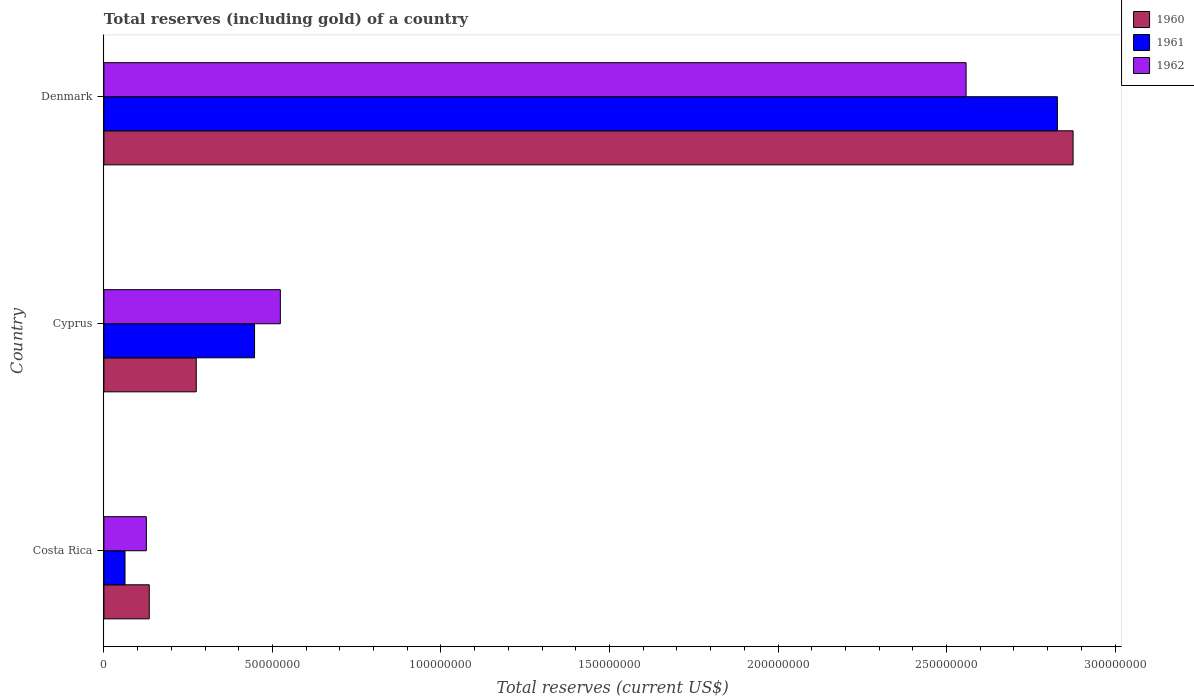How many groups of bars are there?
Make the answer very short. 3. Are the number of bars on each tick of the Y-axis equal?
Provide a succinct answer. Yes. How many bars are there on the 1st tick from the top?
Provide a succinct answer. 3. How many bars are there on the 3rd tick from the bottom?
Provide a short and direct response. 3. What is the label of the 3rd group of bars from the top?
Offer a terse response. Costa Rica. In how many cases, is the number of bars for a given country not equal to the number of legend labels?
Ensure brevity in your answer.  0. What is the total reserves (including gold) in 1961 in Cyprus?
Make the answer very short. 4.47e+07. Across all countries, what is the maximum total reserves (including gold) in 1962?
Give a very brief answer. 2.56e+08. Across all countries, what is the minimum total reserves (including gold) in 1960?
Keep it short and to the point. 1.35e+07. In which country was the total reserves (including gold) in 1961 maximum?
Keep it short and to the point. Denmark. What is the total total reserves (including gold) in 1961 in the graph?
Ensure brevity in your answer.  3.34e+08. What is the difference between the total reserves (including gold) in 1961 in Cyprus and that in Denmark?
Provide a succinct answer. -2.38e+08. What is the difference between the total reserves (including gold) in 1962 in Denmark and the total reserves (including gold) in 1961 in Costa Rica?
Ensure brevity in your answer.  2.50e+08. What is the average total reserves (including gold) in 1962 per country?
Offer a terse response. 1.07e+08. What is the difference between the total reserves (including gold) in 1962 and total reserves (including gold) in 1961 in Denmark?
Keep it short and to the point. -2.71e+07. In how many countries, is the total reserves (including gold) in 1961 greater than 180000000 US$?
Your answer should be compact. 1. What is the ratio of the total reserves (including gold) in 1961 in Cyprus to that in Denmark?
Your answer should be very brief. 0.16. Is the difference between the total reserves (including gold) in 1962 in Costa Rica and Denmark greater than the difference between the total reserves (including gold) in 1961 in Costa Rica and Denmark?
Ensure brevity in your answer.  Yes. What is the difference between the highest and the second highest total reserves (including gold) in 1962?
Offer a very short reply. 2.03e+08. What is the difference between the highest and the lowest total reserves (including gold) in 1961?
Ensure brevity in your answer.  2.77e+08. In how many countries, is the total reserves (including gold) in 1962 greater than the average total reserves (including gold) in 1962 taken over all countries?
Make the answer very short. 1. What does the 1st bar from the top in Denmark represents?
Your answer should be compact. 1962. What does the 2nd bar from the bottom in Cyprus represents?
Offer a terse response. 1961. Is it the case that in every country, the sum of the total reserves (including gold) in 1962 and total reserves (including gold) in 1960 is greater than the total reserves (including gold) in 1961?
Your answer should be very brief. Yes. How many bars are there?
Keep it short and to the point. 9. Are the values on the major ticks of X-axis written in scientific E-notation?
Provide a succinct answer. No. Does the graph contain grids?
Offer a very short reply. No. How many legend labels are there?
Give a very brief answer. 3. How are the legend labels stacked?
Keep it short and to the point. Vertical. What is the title of the graph?
Your response must be concise. Total reserves (including gold) of a country. Does "1997" appear as one of the legend labels in the graph?
Offer a very short reply. No. What is the label or title of the X-axis?
Your response must be concise. Total reserves (current US$). What is the Total reserves (current US$) of 1960 in Costa Rica?
Your response must be concise. 1.35e+07. What is the Total reserves (current US$) in 1961 in Costa Rica?
Offer a very short reply. 6.26e+06. What is the Total reserves (current US$) in 1962 in Costa Rica?
Give a very brief answer. 1.26e+07. What is the Total reserves (current US$) of 1960 in Cyprus?
Your answer should be very brief. 2.74e+07. What is the Total reserves (current US$) in 1961 in Cyprus?
Give a very brief answer. 4.47e+07. What is the Total reserves (current US$) in 1962 in Cyprus?
Offer a very short reply. 5.23e+07. What is the Total reserves (current US$) of 1960 in Denmark?
Your response must be concise. 2.88e+08. What is the Total reserves (current US$) in 1961 in Denmark?
Offer a terse response. 2.83e+08. What is the Total reserves (current US$) in 1962 in Denmark?
Make the answer very short. 2.56e+08. Across all countries, what is the maximum Total reserves (current US$) of 1960?
Keep it short and to the point. 2.88e+08. Across all countries, what is the maximum Total reserves (current US$) of 1961?
Give a very brief answer. 2.83e+08. Across all countries, what is the maximum Total reserves (current US$) in 1962?
Your response must be concise. 2.56e+08. Across all countries, what is the minimum Total reserves (current US$) of 1960?
Your answer should be compact. 1.35e+07. Across all countries, what is the minimum Total reserves (current US$) in 1961?
Provide a short and direct response. 6.26e+06. Across all countries, what is the minimum Total reserves (current US$) of 1962?
Your answer should be compact. 1.26e+07. What is the total Total reserves (current US$) of 1960 in the graph?
Ensure brevity in your answer.  3.28e+08. What is the total Total reserves (current US$) in 1961 in the graph?
Keep it short and to the point. 3.34e+08. What is the total Total reserves (current US$) of 1962 in the graph?
Offer a terse response. 3.21e+08. What is the difference between the Total reserves (current US$) of 1960 in Costa Rica and that in Cyprus?
Make the answer very short. -1.39e+07. What is the difference between the Total reserves (current US$) of 1961 in Costa Rica and that in Cyprus?
Give a very brief answer. -3.84e+07. What is the difference between the Total reserves (current US$) in 1962 in Costa Rica and that in Cyprus?
Provide a succinct answer. -3.98e+07. What is the difference between the Total reserves (current US$) of 1960 in Costa Rica and that in Denmark?
Provide a succinct answer. -2.74e+08. What is the difference between the Total reserves (current US$) in 1961 in Costa Rica and that in Denmark?
Offer a terse response. -2.77e+08. What is the difference between the Total reserves (current US$) in 1962 in Costa Rica and that in Denmark?
Provide a succinct answer. -2.43e+08. What is the difference between the Total reserves (current US$) of 1960 in Cyprus and that in Denmark?
Offer a terse response. -2.60e+08. What is the difference between the Total reserves (current US$) in 1961 in Cyprus and that in Denmark?
Provide a short and direct response. -2.38e+08. What is the difference between the Total reserves (current US$) of 1962 in Cyprus and that in Denmark?
Your response must be concise. -2.03e+08. What is the difference between the Total reserves (current US$) in 1960 in Costa Rica and the Total reserves (current US$) in 1961 in Cyprus?
Your answer should be very brief. -3.12e+07. What is the difference between the Total reserves (current US$) in 1960 in Costa Rica and the Total reserves (current US$) in 1962 in Cyprus?
Offer a very short reply. -3.89e+07. What is the difference between the Total reserves (current US$) of 1961 in Costa Rica and the Total reserves (current US$) of 1962 in Cyprus?
Keep it short and to the point. -4.61e+07. What is the difference between the Total reserves (current US$) of 1960 in Costa Rica and the Total reserves (current US$) of 1961 in Denmark?
Give a very brief answer. -2.69e+08. What is the difference between the Total reserves (current US$) of 1960 in Costa Rica and the Total reserves (current US$) of 1962 in Denmark?
Provide a succinct answer. -2.42e+08. What is the difference between the Total reserves (current US$) in 1961 in Costa Rica and the Total reserves (current US$) in 1962 in Denmark?
Provide a short and direct response. -2.50e+08. What is the difference between the Total reserves (current US$) in 1960 in Cyprus and the Total reserves (current US$) in 1961 in Denmark?
Your answer should be compact. -2.55e+08. What is the difference between the Total reserves (current US$) in 1960 in Cyprus and the Total reserves (current US$) in 1962 in Denmark?
Make the answer very short. -2.28e+08. What is the difference between the Total reserves (current US$) of 1961 in Cyprus and the Total reserves (current US$) of 1962 in Denmark?
Your response must be concise. -2.11e+08. What is the average Total reserves (current US$) in 1960 per country?
Give a very brief answer. 1.09e+08. What is the average Total reserves (current US$) of 1961 per country?
Provide a short and direct response. 1.11e+08. What is the average Total reserves (current US$) in 1962 per country?
Your response must be concise. 1.07e+08. What is the difference between the Total reserves (current US$) of 1960 and Total reserves (current US$) of 1961 in Costa Rica?
Keep it short and to the point. 7.20e+06. What is the difference between the Total reserves (current US$) of 1960 and Total reserves (current US$) of 1962 in Costa Rica?
Keep it short and to the point. 8.62e+05. What is the difference between the Total reserves (current US$) in 1961 and Total reserves (current US$) in 1962 in Costa Rica?
Your answer should be very brief. -6.34e+06. What is the difference between the Total reserves (current US$) in 1960 and Total reserves (current US$) in 1961 in Cyprus?
Keep it short and to the point. -1.73e+07. What is the difference between the Total reserves (current US$) in 1960 and Total reserves (current US$) in 1962 in Cyprus?
Provide a succinct answer. -2.49e+07. What is the difference between the Total reserves (current US$) in 1961 and Total reserves (current US$) in 1962 in Cyprus?
Provide a short and direct response. -7.65e+06. What is the difference between the Total reserves (current US$) in 1960 and Total reserves (current US$) in 1961 in Denmark?
Provide a short and direct response. 4.67e+06. What is the difference between the Total reserves (current US$) in 1960 and Total reserves (current US$) in 1962 in Denmark?
Make the answer very short. 3.17e+07. What is the difference between the Total reserves (current US$) in 1961 and Total reserves (current US$) in 1962 in Denmark?
Your answer should be very brief. 2.71e+07. What is the ratio of the Total reserves (current US$) in 1960 in Costa Rica to that in Cyprus?
Give a very brief answer. 0.49. What is the ratio of the Total reserves (current US$) of 1961 in Costa Rica to that in Cyprus?
Your answer should be very brief. 0.14. What is the ratio of the Total reserves (current US$) in 1962 in Costa Rica to that in Cyprus?
Offer a terse response. 0.24. What is the ratio of the Total reserves (current US$) of 1960 in Costa Rica to that in Denmark?
Offer a terse response. 0.05. What is the ratio of the Total reserves (current US$) in 1961 in Costa Rica to that in Denmark?
Your answer should be compact. 0.02. What is the ratio of the Total reserves (current US$) of 1962 in Costa Rica to that in Denmark?
Offer a terse response. 0.05. What is the ratio of the Total reserves (current US$) of 1960 in Cyprus to that in Denmark?
Your response must be concise. 0.1. What is the ratio of the Total reserves (current US$) of 1961 in Cyprus to that in Denmark?
Give a very brief answer. 0.16. What is the ratio of the Total reserves (current US$) of 1962 in Cyprus to that in Denmark?
Your answer should be very brief. 0.2. What is the difference between the highest and the second highest Total reserves (current US$) of 1960?
Give a very brief answer. 2.60e+08. What is the difference between the highest and the second highest Total reserves (current US$) of 1961?
Make the answer very short. 2.38e+08. What is the difference between the highest and the second highest Total reserves (current US$) of 1962?
Your answer should be compact. 2.03e+08. What is the difference between the highest and the lowest Total reserves (current US$) in 1960?
Provide a succinct answer. 2.74e+08. What is the difference between the highest and the lowest Total reserves (current US$) in 1961?
Provide a short and direct response. 2.77e+08. What is the difference between the highest and the lowest Total reserves (current US$) of 1962?
Your answer should be compact. 2.43e+08. 